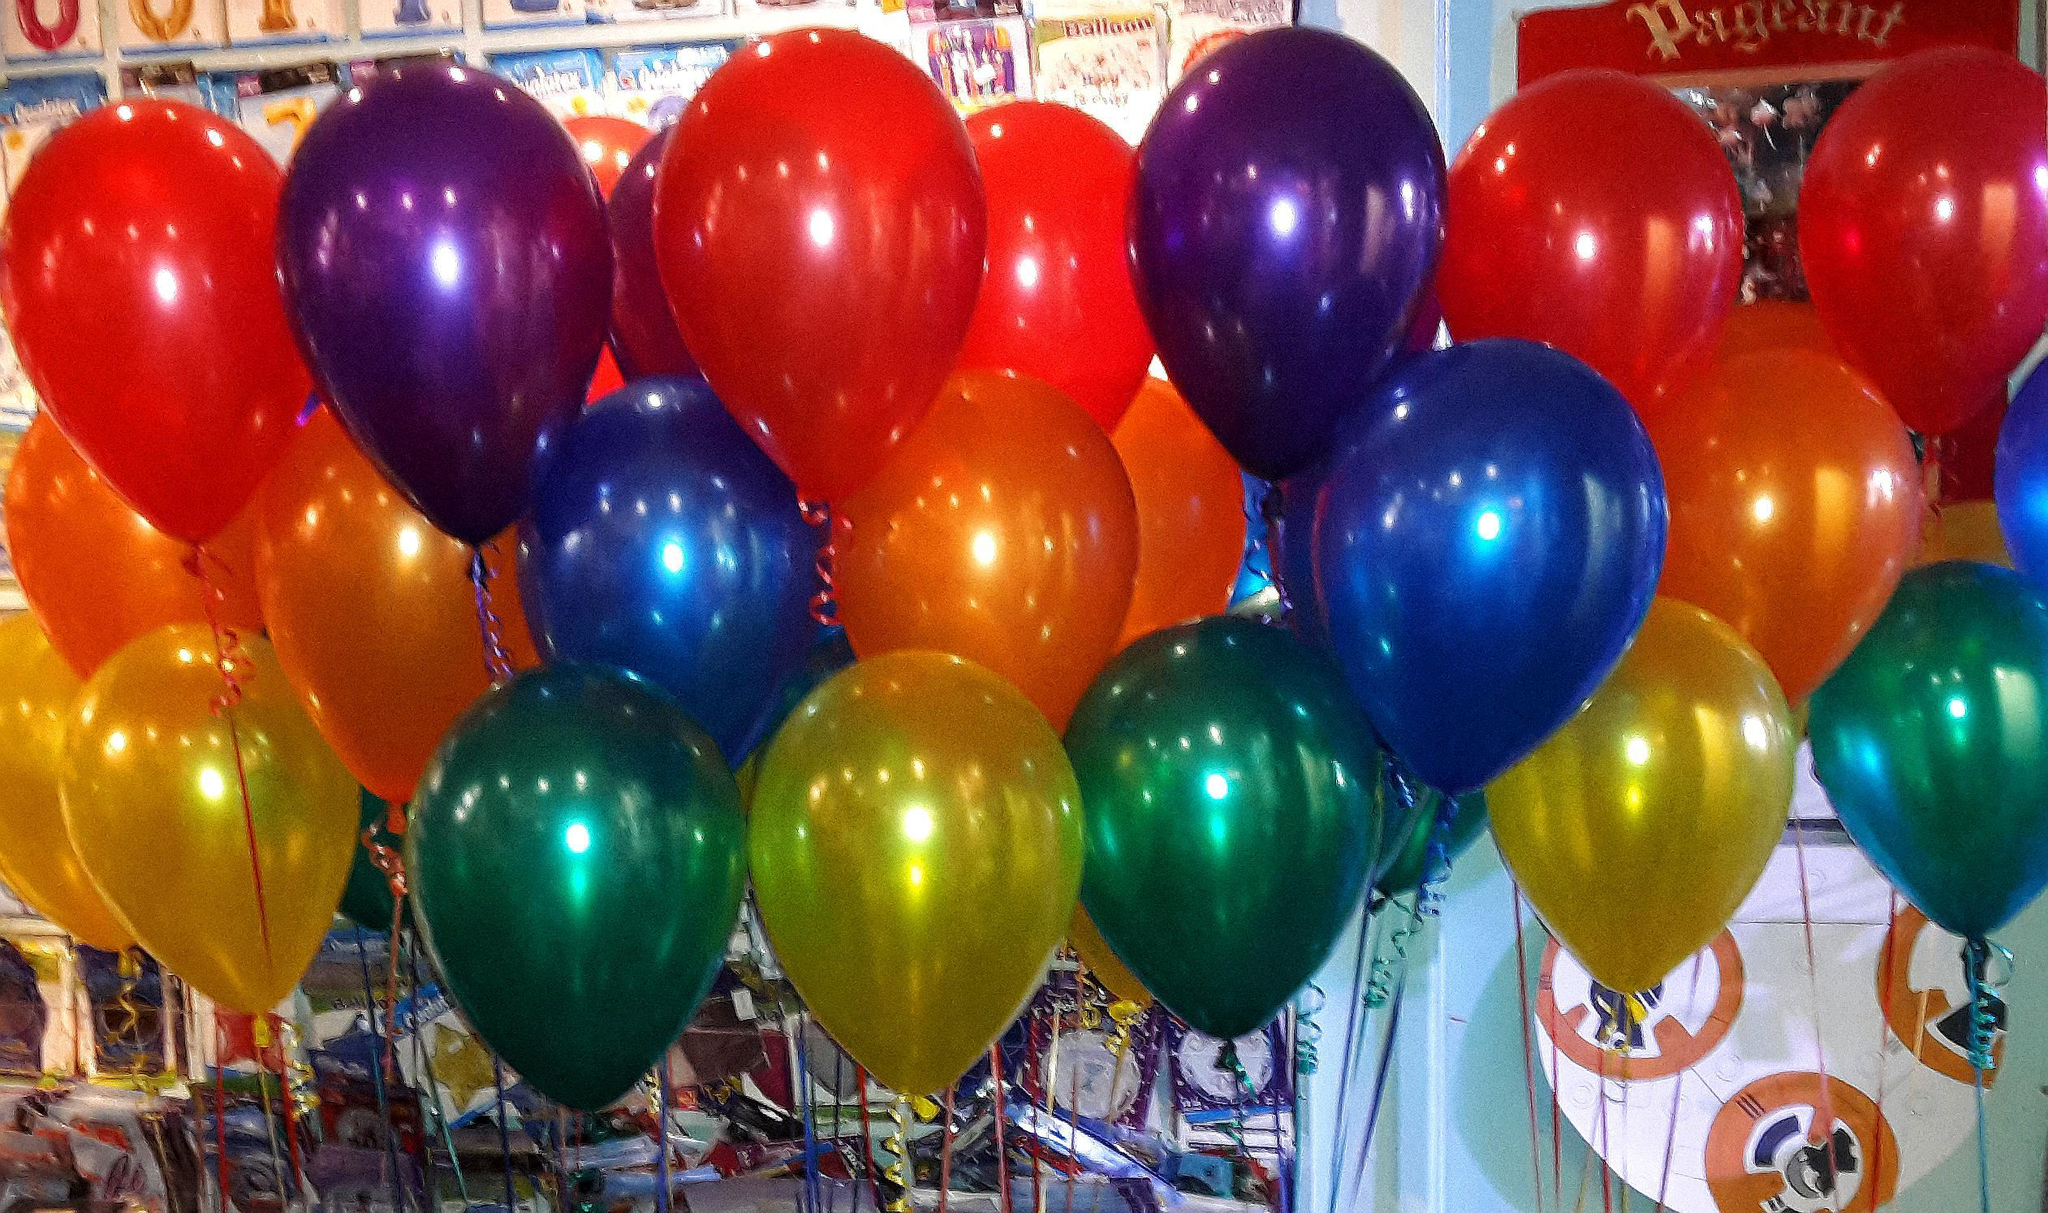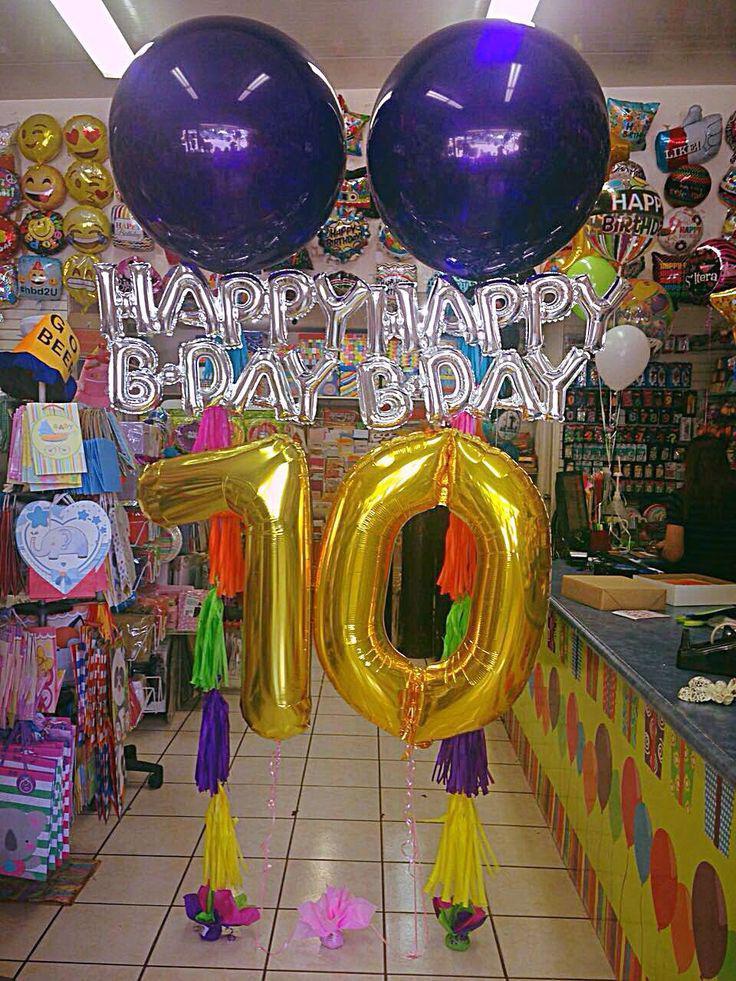The first image is the image on the left, the second image is the image on the right. Considering the images on both sides, is "There are solid red balloons in the right image, and green balloons in the left." valid? Answer yes or no. No. The first image is the image on the left, the second image is the image on the right. For the images displayed, is the sentence "There are at least 15 balloons inside a party shop or ballon store." factually correct? Answer yes or no. Yes. 